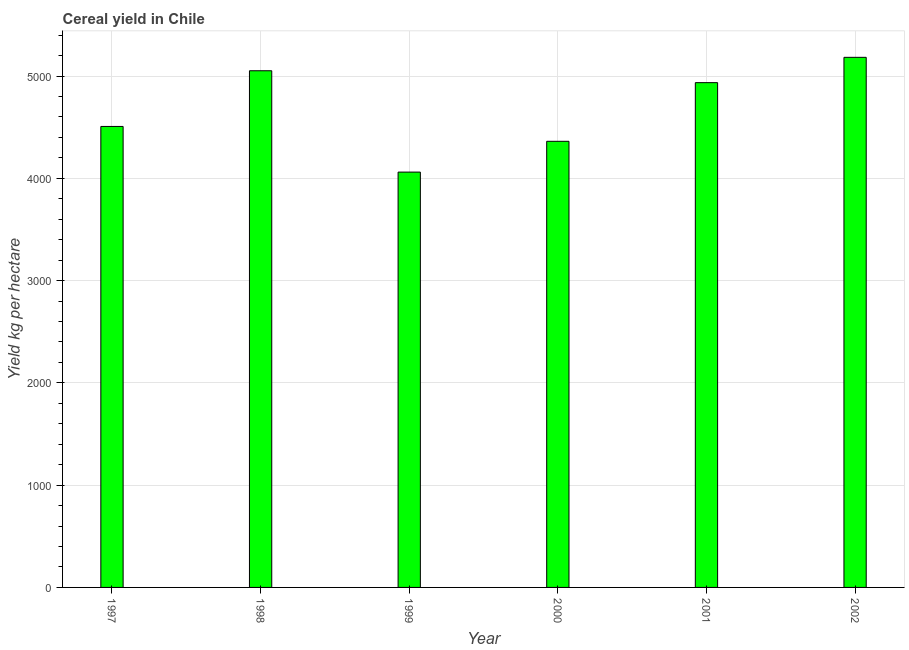What is the title of the graph?
Give a very brief answer. Cereal yield in Chile. What is the label or title of the Y-axis?
Provide a short and direct response. Yield kg per hectare. What is the cereal yield in 1999?
Offer a terse response. 4061.15. Across all years, what is the maximum cereal yield?
Provide a short and direct response. 5183.33. Across all years, what is the minimum cereal yield?
Give a very brief answer. 4061.15. What is the sum of the cereal yield?
Provide a succinct answer. 2.81e+04. What is the difference between the cereal yield in 1999 and 2000?
Your answer should be very brief. -301. What is the average cereal yield per year?
Offer a very short reply. 4683.63. What is the median cereal yield?
Keep it short and to the point. 4721.57. In how many years, is the cereal yield greater than 3000 kg per hectare?
Offer a very short reply. 6. What is the ratio of the cereal yield in 1999 to that in 2000?
Offer a terse response. 0.93. What is the difference between the highest and the second highest cereal yield?
Offer a very short reply. 131.3. What is the difference between the highest and the lowest cereal yield?
Your answer should be compact. 1122.18. Are all the bars in the graph horizontal?
Your answer should be compact. No. What is the difference between two consecutive major ticks on the Y-axis?
Ensure brevity in your answer.  1000. What is the Yield kg per hectare in 1997?
Your answer should be very brief. 4507.47. What is the Yield kg per hectare in 1998?
Your answer should be compact. 5052.02. What is the Yield kg per hectare in 1999?
Offer a very short reply. 4061.15. What is the Yield kg per hectare in 2000?
Give a very brief answer. 4362.14. What is the Yield kg per hectare in 2001?
Your answer should be compact. 4935.68. What is the Yield kg per hectare in 2002?
Give a very brief answer. 5183.33. What is the difference between the Yield kg per hectare in 1997 and 1998?
Your answer should be very brief. -544.56. What is the difference between the Yield kg per hectare in 1997 and 1999?
Your answer should be compact. 446.32. What is the difference between the Yield kg per hectare in 1997 and 2000?
Give a very brief answer. 145.32. What is the difference between the Yield kg per hectare in 1997 and 2001?
Provide a succinct answer. -428.22. What is the difference between the Yield kg per hectare in 1997 and 2002?
Offer a terse response. -675.86. What is the difference between the Yield kg per hectare in 1998 and 1999?
Ensure brevity in your answer.  990.88. What is the difference between the Yield kg per hectare in 1998 and 2000?
Offer a terse response. 689.88. What is the difference between the Yield kg per hectare in 1998 and 2001?
Give a very brief answer. 116.34. What is the difference between the Yield kg per hectare in 1998 and 2002?
Offer a very short reply. -131.3. What is the difference between the Yield kg per hectare in 1999 and 2000?
Give a very brief answer. -301. What is the difference between the Yield kg per hectare in 1999 and 2001?
Offer a very short reply. -874.54. What is the difference between the Yield kg per hectare in 1999 and 2002?
Offer a very short reply. -1122.18. What is the difference between the Yield kg per hectare in 2000 and 2001?
Offer a very short reply. -573.54. What is the difference between the Yield kg per hectare in 2000 and 2002?
Provide a short and direct response. -821.18. What is the difference between the Yield kg per hectare in 2001 and 2002?
Provide a short and direct response. -247.64. What is the ratio of the Yield kg per hectare in 1997 to that in 1998?
Offer a terse response. 0.89. What is the ratio of the Yield kg per hectare in 1997 to that in 1999?
Offer a very short reply. 1.11. What is the ratio of the Yield kg per hectare in 1997 to that in 2000?
Your response must be concise. 1.03. What is the ratio of the Yield kg per hectare in 1997 to that in 2002?
Offer a terse response. 0.87. What is the ratio of the Yield kg per hectare in 1998 to that in 1999?
Your response must be concise. 1.24. What is the ratio of the Yield kg per hectare in 1998 to that in 2000?
Provide a short and direct response. 1.16. What is the ratio of the Yield kg per hectare in 1998 to that in 2001?
Ensure brevity in your answer.  1.02. What is the ratio of the Yield kg per hectare in 1999 to that in 2000?
Give a very brief answer. 0.93. What is the ratio of the Yield kg per hectare in 1999 to that in 2001?
Ensure brevity in your answer.  0.82. What is the ratio of the Yield kg per hectare in 1999 to that in 2002?
Ensure brevity in your answer.  0.78. What is the ratio of the Yield kg per hectare in 2000 to that in 2001?
Give a very brief answer. 0.88. What is the ratio of the Yield kg per hectare in 2000 to that in 2002?
Provide a succinct answer. 0.84. What is the ratio of the Yield kg per hectare in 2001 to that in 2002?
Provide a succinct answer. 0.95. 